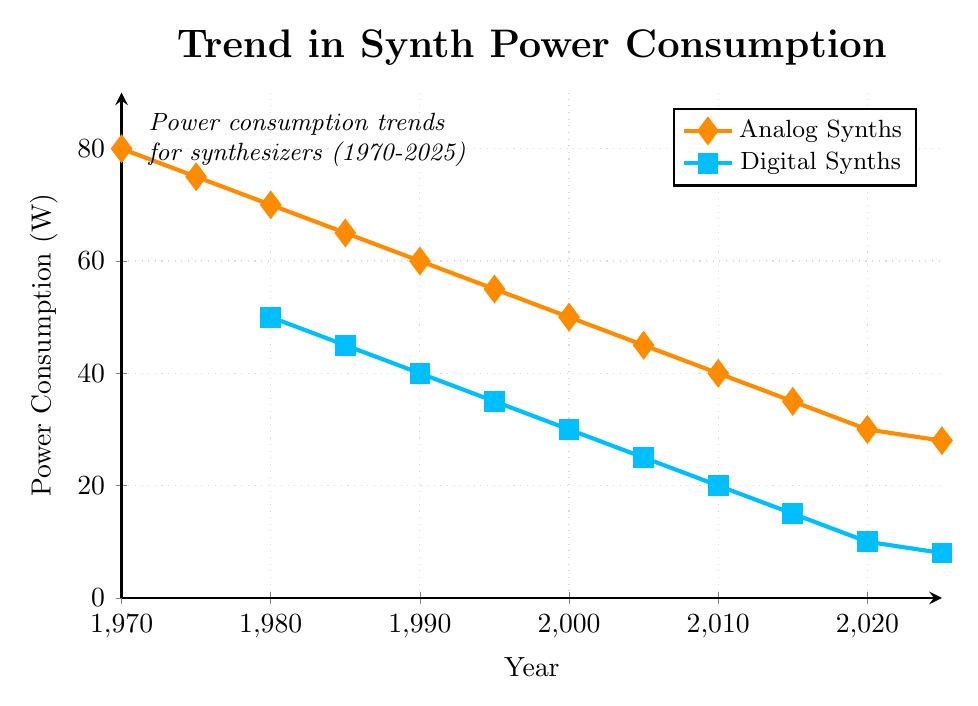what trend do you observe in the power consumption of analog synths from 1970 to 2025? The trend for the power consumption of analog synths decreases consistently over time. It starts at 80W in 1970 and gradually declines to 28W by 2025.
Answer: Decreasing trend how does the power consumption of digital synths compare to analog synths in 1980? In 1980, analog synths consumed 70W while digital synths consumed 50W. By comparing these values, we can see that analog synths consumed more power than digital synths in 1980.
Answer: Analog synths consume more power what visual differences do you see between the analog and digital synth lines on the chart? The line representing the power consumption of analog synths is marked with diamond shapes and has an orange color. The line representing digital synths is marked with square shapes and has a blue color.
Answer: Different shapes and colors in which year do both analog and digital synths show the highest power consumption? For analog synths, the highest power consumption occurs in 1970 at 80W. For digital synths, the highest power consumption occurs in 1980 at 50W.
Answer: 1970 for analog, 1980 for digital what is the average power consumption of analog synths over the years provided? The sum of the power consumption for analog synths over the given years is (80 + 75 + 70 + 65 + 60 + 55 + 50 + 45 + 40 + 35 + 30 + 28) = 633. There are 12 data points, so the average is 633/12 ≈ 52.75W.
Answer: 52.75W which type of synth shows a steeper decline in power consumption from 2000 to 2025? The power consumption of analog synths decreases from 50W in 2000 to 28W in 2025, a decline of 22W. Digital synths decrease from 30W in 2000 to 8W in 2025, a decline of 22W. Both types show an equal decline over this period.
Answer: Equal decline how much less power do digital synths consume in 2025 compared to 2020? In 2025, digital synths consume 8W, and in 2020, they consume 10W. The difference is 10W - 8W = 2W.
Answer: 2W less what is the combined power consumption of both types of synths in 2010? In 2010, the power consumption is 40W for analog synths and 20W for digital synths. The combined total is 40W + 20W = 60W.
Answer: 60W how does the power consumption trend for digital synths from 1980 to 2000 compare to that of analog synths from 1970 to 1990? Digital synths decrease from 50W in 1980 to 30W in 2000, a decline of 20W over 20 years. Analog synths decrease from 80W in 1970 to 60W in 1990, a decline of 20W over 20 years. Both trends show an equal decline over their respective periods.
Answer: Equal decline 